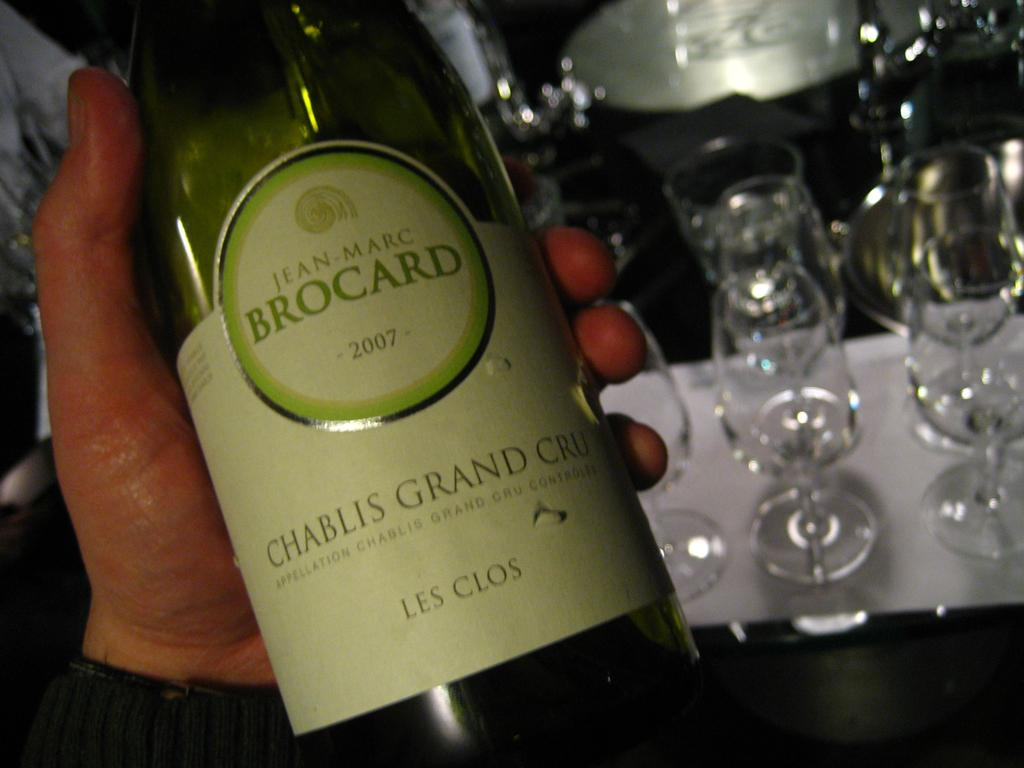Who or what is present in the image? There is a person in the image. What is the person holding in the image? The person is holding a bottle. Can you describe the bottle in more detail? The bottle has a sticker on it. What else can be seen in the background of the image? There are glasses in the background of the image. What type of drug is the person taking in the image? There is no indication in the image that the person is taking any drug, and therefore it cannot be determined from the picture. 